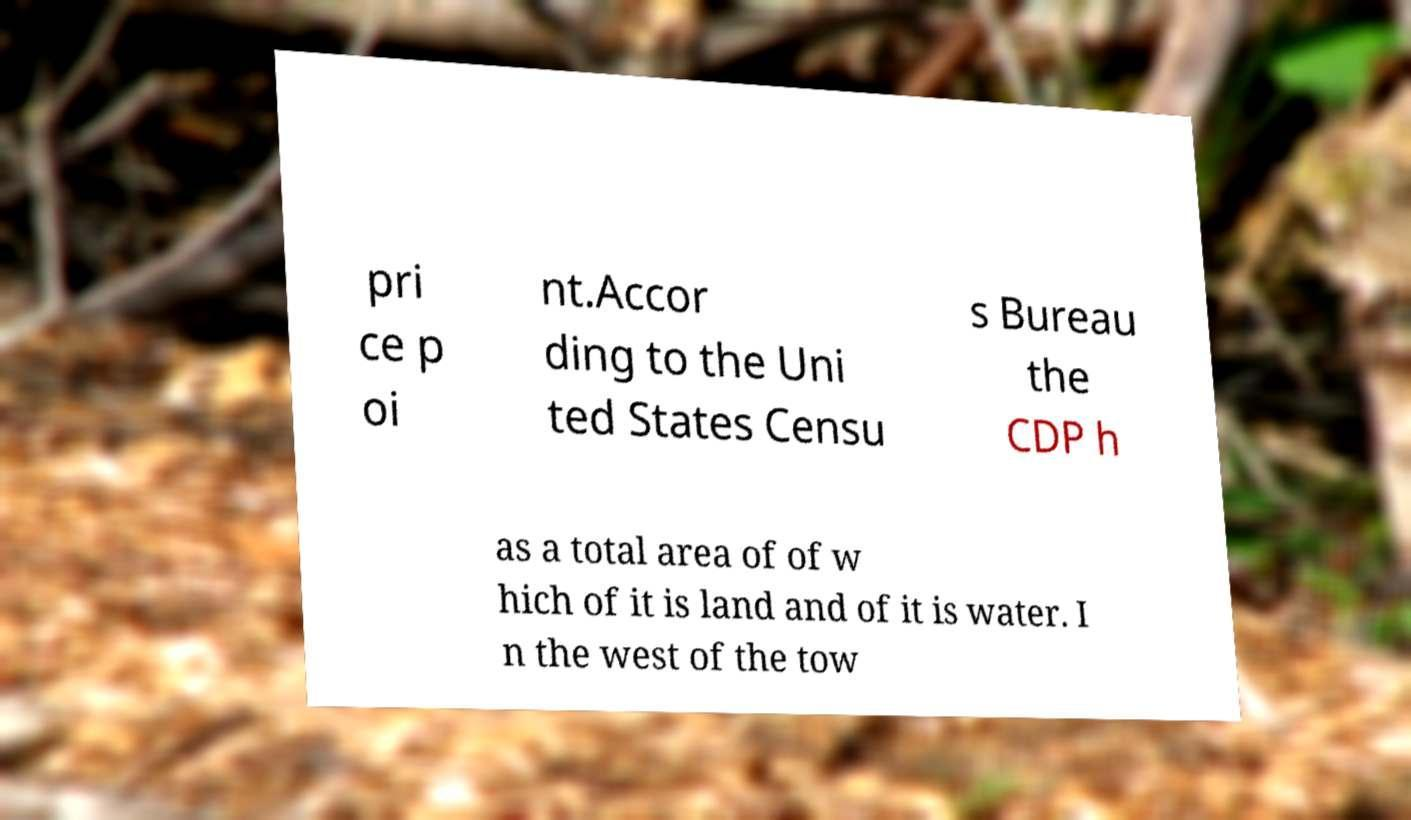Could you assist in decoding the text presented in this image and type it out clearly? pri ce p oi nt.Accor ding to the Uni ted States Censu s Bureau the CDP h as a total area of of w hich of it is land and of it is water. I n the west of the tow 